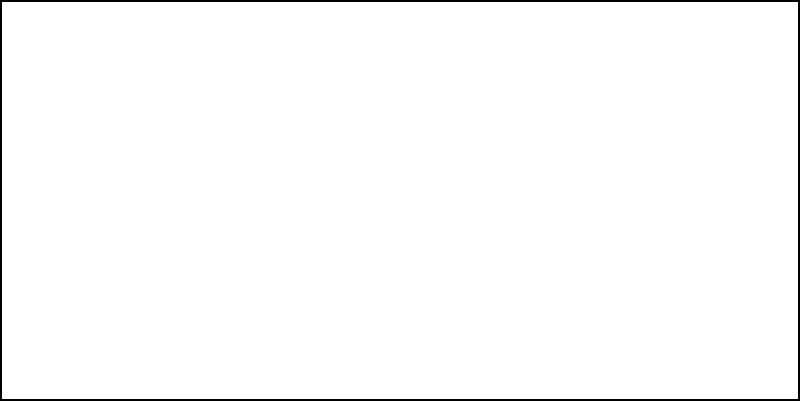Based on the heat map overlay of a performer's movement across the Eurovision stage, which area shows the highest energy expenditure, and what factors might contribute to this pattern? To analyze the heat map and determine the area of highest energy expenditure:

1. Observe the color gradient: The heat map uses a color spectrum from cool (blue) to warm (red) colors.

2. Identify the hotspot: The center of the stage shows the warmest colors (red and orange), indicating the highest energy expenditure.

3. Consider contributing factors:
   a) Choreography: Complex dance moves or high-intensity performances often occur center stage.
   b) Lighting: The center is typically the most well-lit area, encouraging more dynamic performances.
   c) Camera focus: Performers tend to be more active in areas where they know cameras are focused.
   d) Audience engagement: The center provides the best vantage point for connecting with the live and TV audience.

4. Analyze the pattern:
   The energy expenditure decreases towards the edges of the stage, shown by cooler colors (green and blue).
   This could be due to:
   - Less frequent use of stage edges
   - Simpler movements or resting positions at the sides
   - Transitions between main performance segments

5. Consider the implications:
   - Stage design: Ensure the center can withstand intense activity
   - Camera work: Focus on the high-energy center for dynamic shots
   - Performance planning: Advise artists to use the full stage to manage energy levels throughout the performance

Understanding this pattern helps in optimizing stage design, performance choreography, and broadcast planning to capture the most engaging moments of the Eurovision performances.
Answer: Center stage; choreography, lighting, camera focus, and audience engagement 